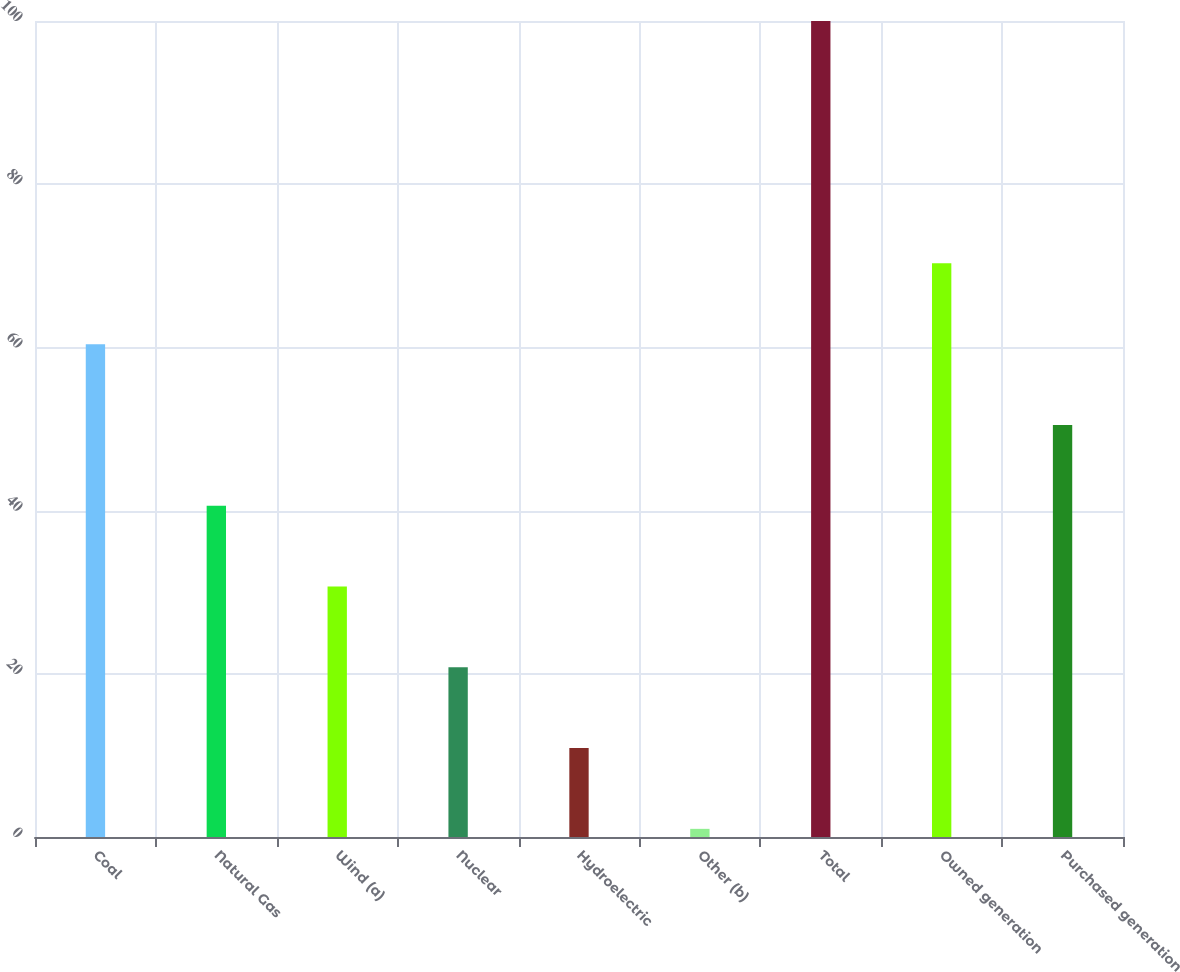Convert chart to OTSL. <chart><loc_0><loc_0><loc_500><loc_500><bar_chart><fcel>Coal<fcel>Natural Gas<fcel>Wind (a)<fcel>Nuclear<fcel>Hydroelectric<fcel>Other (b)<fcel>Total<fcel>Owned generation<fcel>Purchased generation<nl><fcel>60.4<fcel>40.6<fcel>30.7<fcel>20.8<fcel>10.9<fcel>1<fcel>100<fcel>70.3<fcel>50.5<nl></chart> 